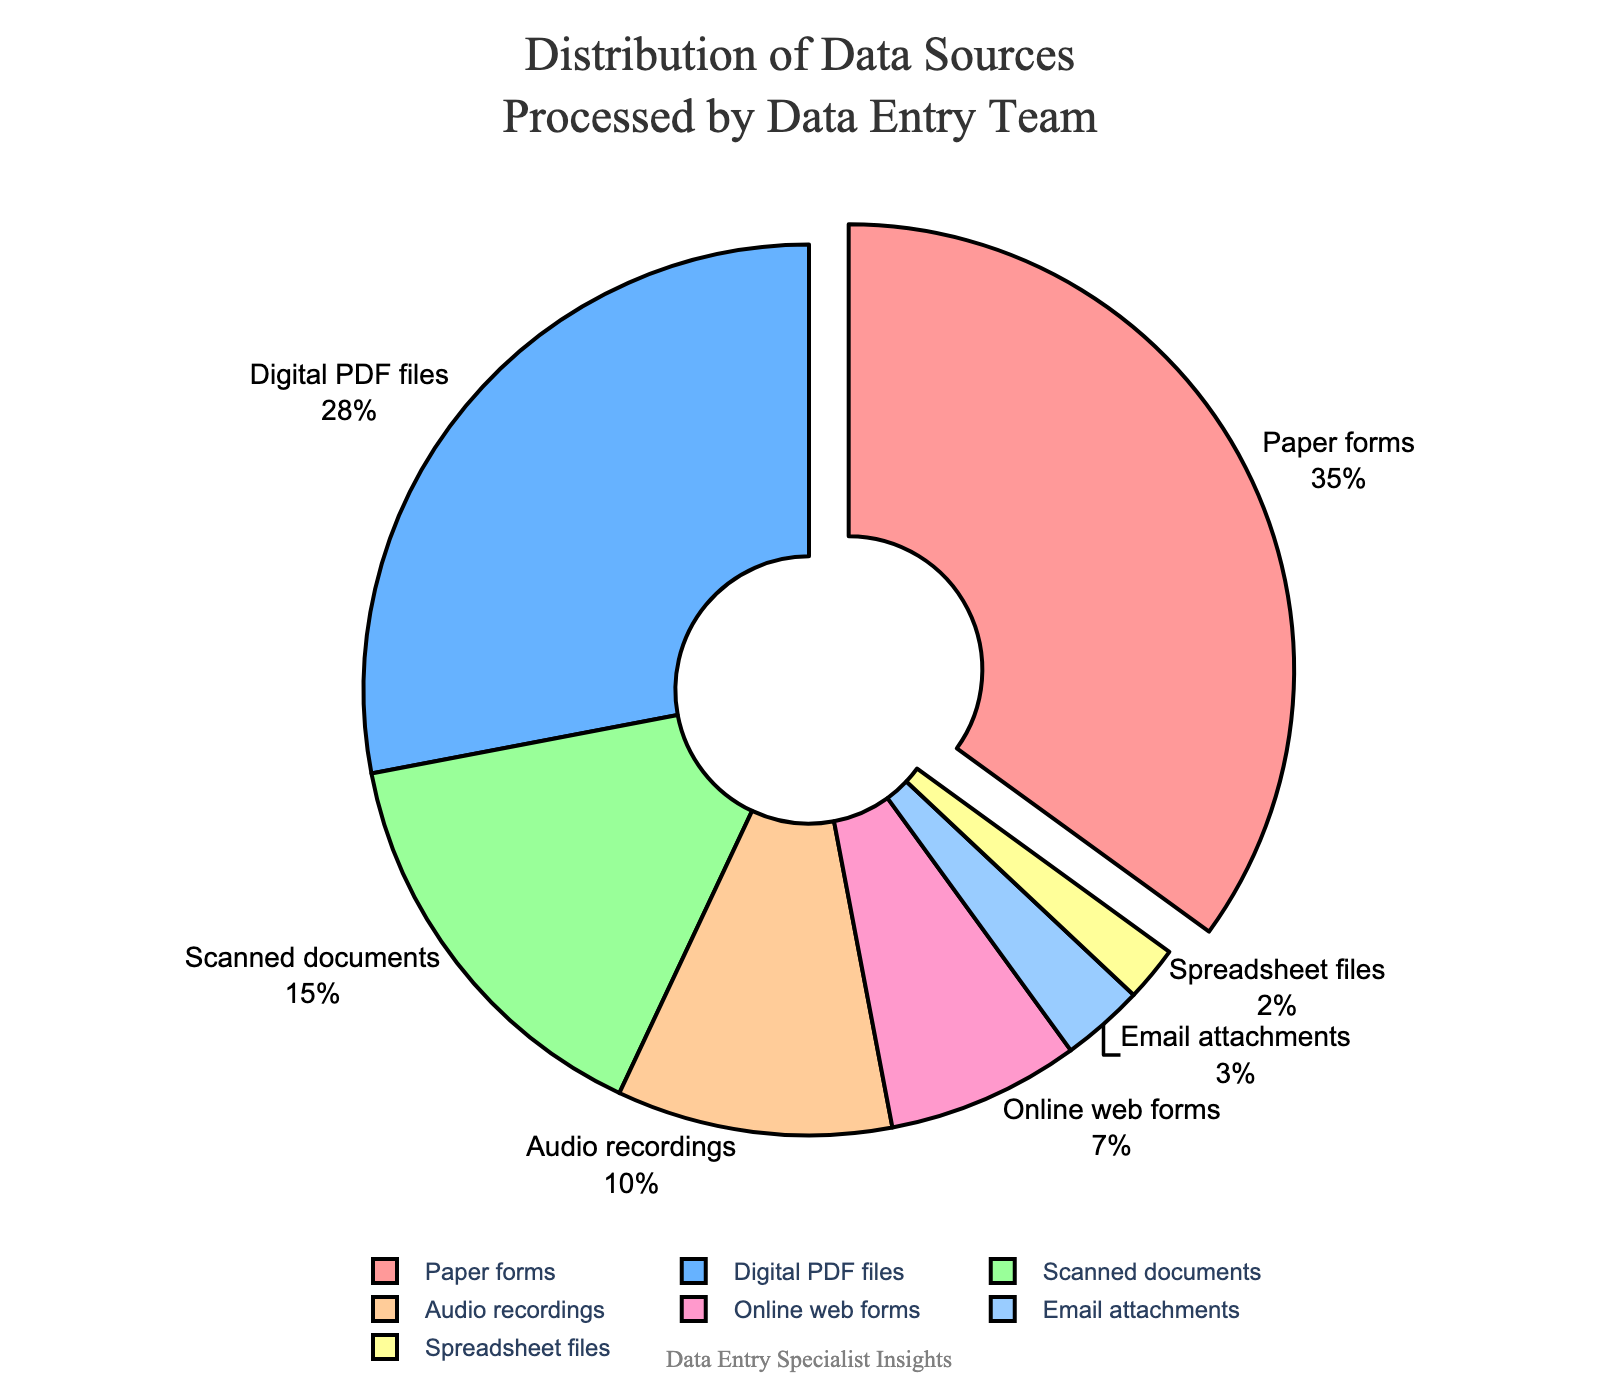Which data source has the highest percentage? The figure shows that paper forms have the largest segment pulled out from the pie chart, indicating it has the highest percentage.
Answer: Paper forms How much larger is the percentage of digital PDF files compared to email attachments? According to the figure, digital PDF files make up 28% while email attachments make up 3%. The difference is calculated as 28% - 3% = 25%.
Answer: 25% What is the combined percentage of audio recordings and online web forms? From the figure, audio recordings account for 10% and online web forms account for 7%. Adding these percentages gives 10% + 7% = 17%.
Answer: 17% Which data source has a smaller percentage than scanned documents but larger than spreadsheet files? The pie chart indicates scanned documents are at 15%, and spreadsheet files are at 2%. Thus, a data source between these percentages is audio recordings at 10%.
Answer: Audio recordings Is the percentage of online web forms more than the sum of email attachments and spreadsheet files? Online web forms account for 7%. The combined percentage of email attachments (3%) and spreadsheet files (2%) is 3% + 2% = 5%. Hence, 7% is greater than 5%.
Answer: Yes What is the percentage range that most data sources fall within? Considering the different segments of the pie chart, most data sources fall within a 7% to 35% range. This includes paper forms, digital PDF files, scanned documents, audio recordings, and online web forms.
Answer: 7% to 35% Which category represents the smallest portion of the data sources? The pie chart shows that the smallest segment is for spreadsheet files, which is 2%.
Answer: Spreadsheet files In the pie chart, which data sources combined exceed half (i.e., 50%) of the total distribution? From the chart, paper forms (35%) and digital PDF files (28%) together make up 35% + 28% = 63%, which exceeds half of the total distribution.
Answer: Paper forms and digital PDF files How does the proportion of scanned documents compare to digital PDF files? According to the pie chart, scanned documents represent 15%, whereas digital PDF files represent 28%. Scanned documents have a smaller proportion than digital PDF files.
Answer: Scanned documents are smaller If the pie chart segments were colored in the following order: red, blue, green, orange, pink, light blue, and yellow, which data source is represented by the orange color? Based on the sequential color assignment and the figure's visual segmented order: red (Paper forms), blue (Digital PDF files), green (Scanned documents), orange would be Audio recordings (10%).
Answer: Audio recordings 